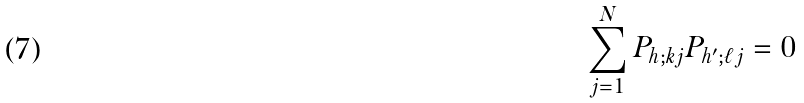Convert formula to latex. <formula><loc_0><loc_0><loc_500><loc_500>\sum _ { j = 1 } ^ { N } P _ { h ; k j } P _ { h ^ { \prime } ; \ell j } = 0</formula> 